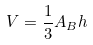Convert formula to latex. <formula><loc_0><loc_0><loc_500><loc_500>V = \frac { 1 } { 3 } A _ { B } h</formula> 